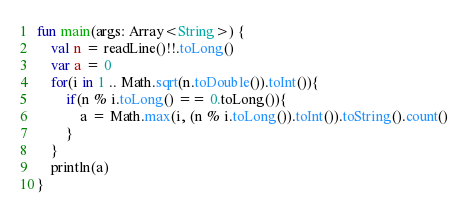Convert code to text. <code><loc_0><loc_0><loc_500><loc_500><_Kotlin_>fun main(args: Array<String>) {
    val n = readLine()!!.toLong()
    var a = 0
    for(i in 1 .. Math.sqrt(n.toDouble()).toInt()){
        if(n % i.toLong() == 0.toLong()){
            a = Math.max(i, (n % i.toLong()).toInt()).toString().count()
        }
    }
    println(a)
}</code> 